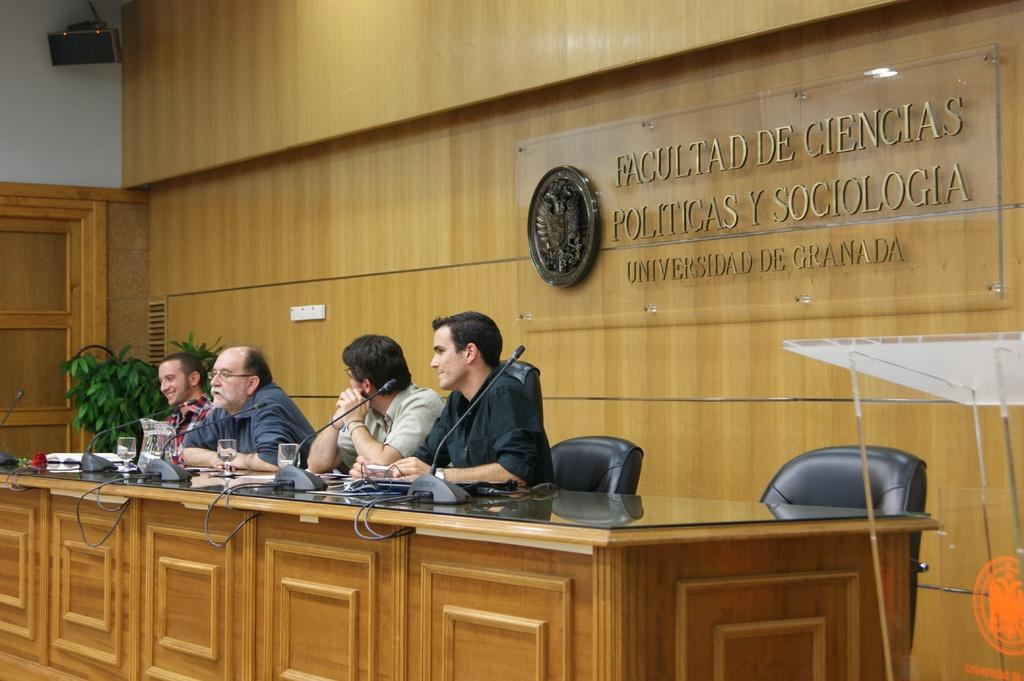What are the people in the image doing? The people in the image are sitting on chairs. What is on the table in the image? There is a microphone with a stand and wine glasses on the table. What can be seen on the wall in the background? There is a banner on the wall in the background. What type of hair is being distributed to the audience in the image? There is no hair being distributed in the image; the microphone and wine glasses are the main objects on the table. 